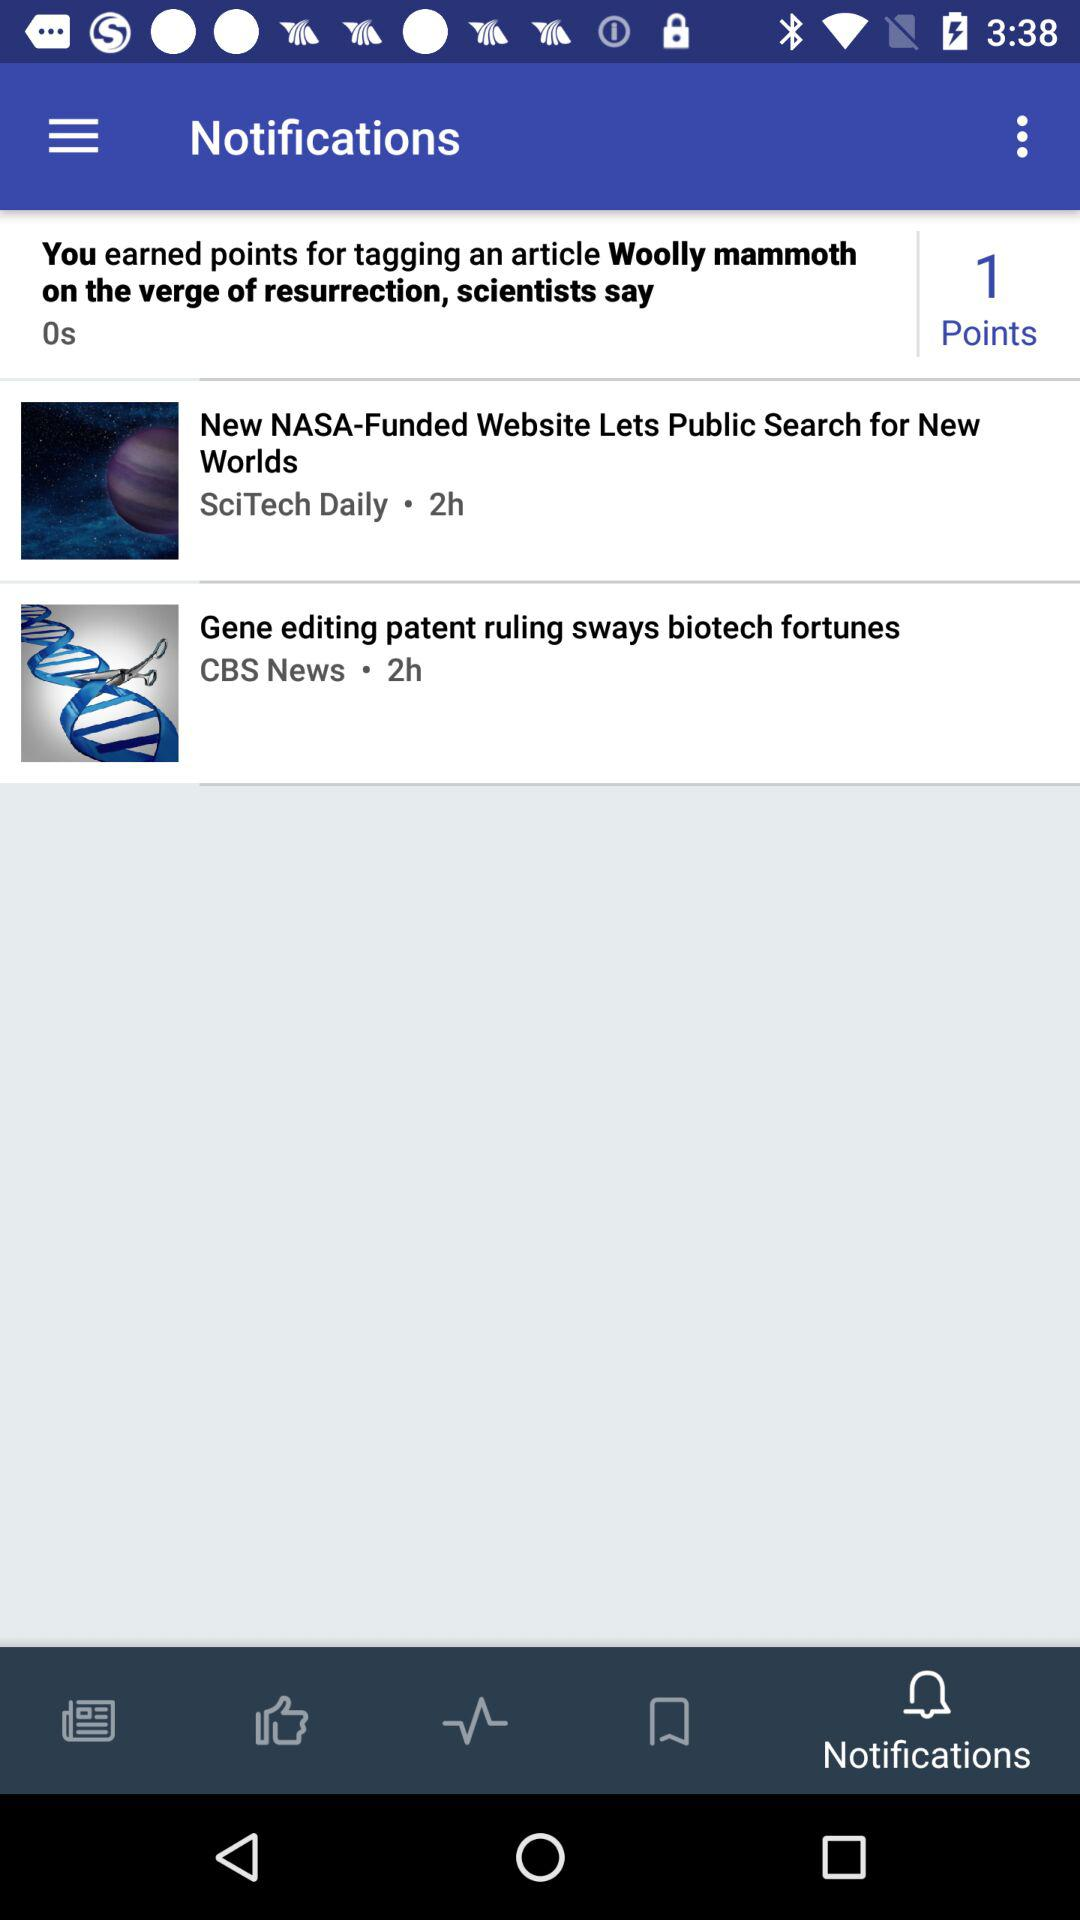How recently did SciTech Daily update a post? "SciTech Daily" updated a post 2 hours ago. 